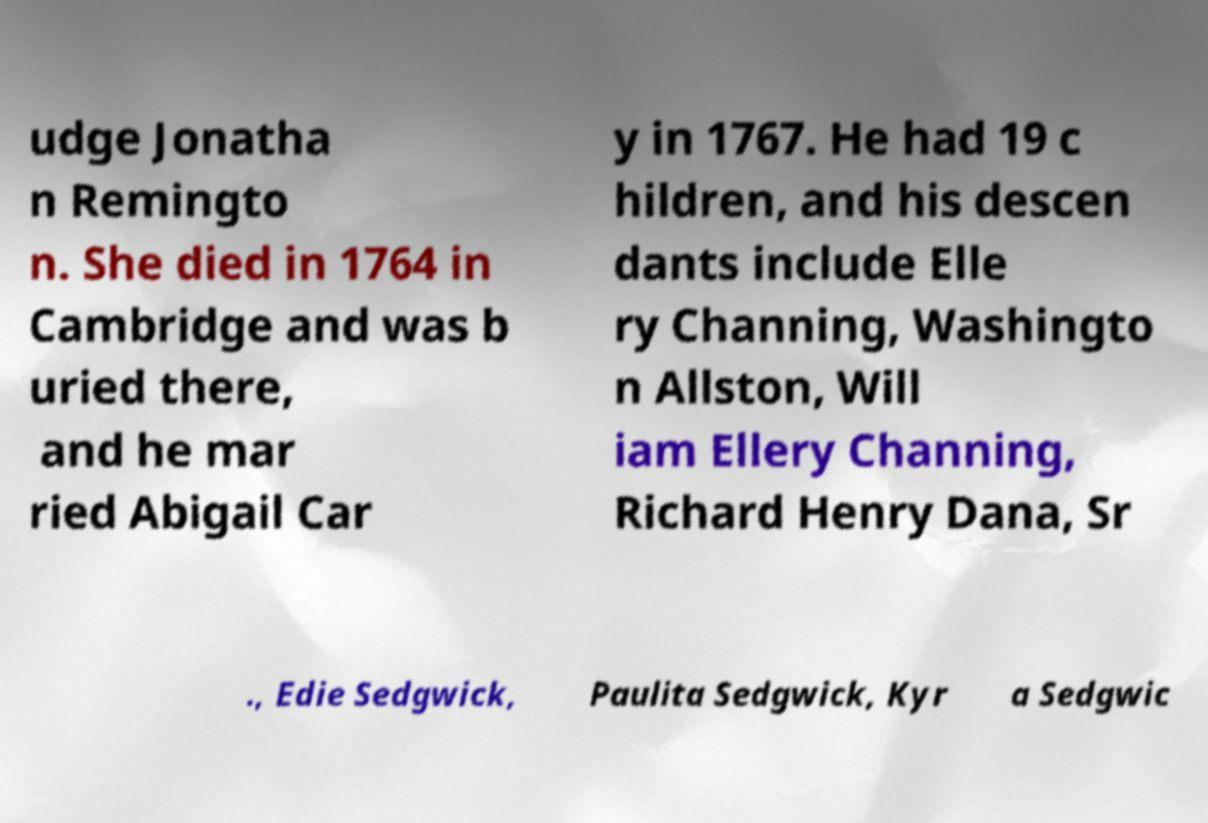Can you read and provide the text displayed in the image?This photo seems to have some interesting text. Can you extract and type it out for me? udge Jonatha n Remingto n. She died in 1764 in Cambridge and was b uried there, and he mar ried Abigail Car y in 1767. He had 19 c hildren, and his descen dants include Elle ry Channing, Washingto n Allston, Will iam Ellery Channing, Richard Henry Dana, Sr ., Edie Sedgwick, Paulita Sedgwick, Kyr a Sedgwic 